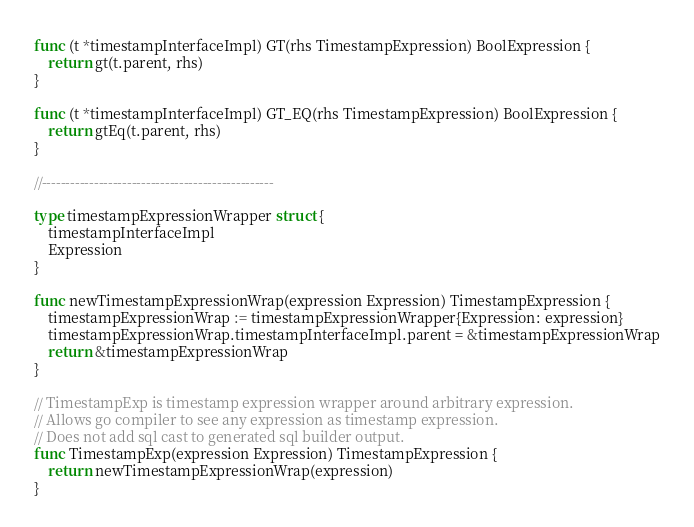Convert code to text. <code><loc_0><loc_0><loc_500><loc_500><_Go_>
func (t *timestampInterfaceImpl) GT(rhs TimestampExpression) BoolExpression {
	return gt(t.parent, rhs)
}

func (t *timestampInterfaceImpl) GT_EQ(rhs TimestampExpression) BoolExpression {
	return gtEq(t.parent, rhs)
}

//-------------------------------------------------

type timestampExpressionWrapper struct {
	timestampInterfaceImpl
	Expression
}

func newTimestampExpressionWrap(expression Expression) TimestampExpression {
	timestampExpressionWrap := timestampExpressionWrapper{Expression: expression}
	timestampExpressionWrap.timestampInterfaceImpl.parent = &timestampExpressionWrap
	return &timestampExpressionWrap
}

// TimestampExp is timestamp expression wrapper around arbitrary expression.
// Allows go compiler to see any expression as timestamp expression.
// Does not add sql cast to generated sql builder output.
func TimestampExp(expression Expression) TimestampExpression {
	return newTimestampExpressionWrap(expression)
}
</code> 